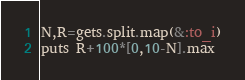<code> <loc_0><loc_0><loc_500><loc_500><_Ruby_>N,R=gets.split.map(&:to_i)
puts R+100*[0,10-N].max</code> 